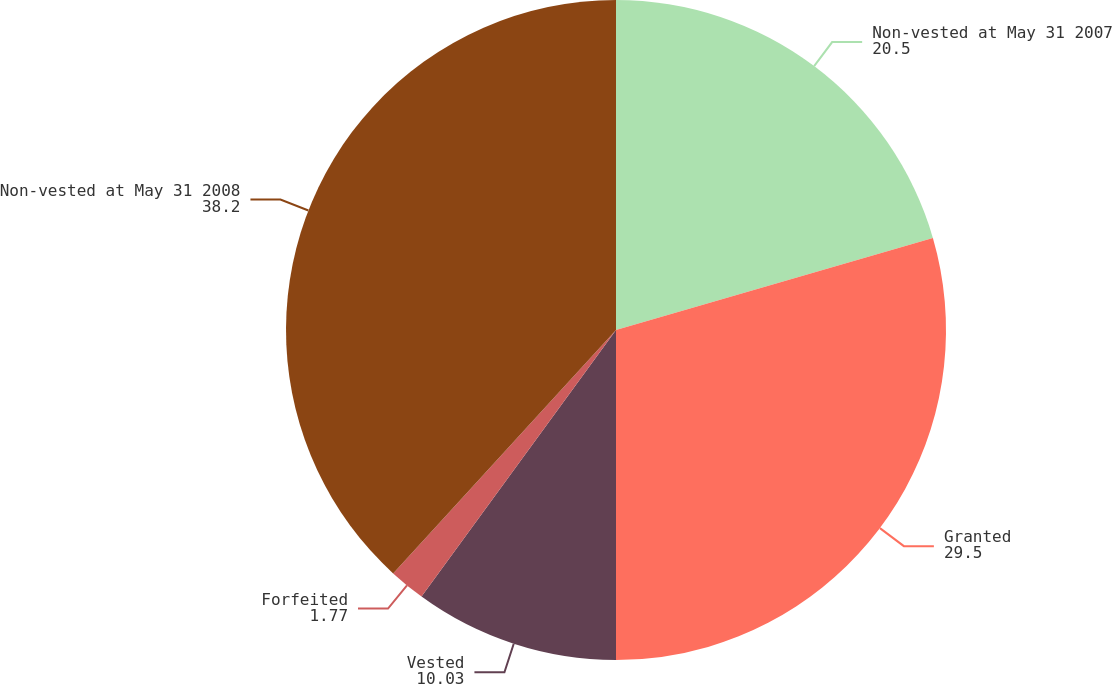Convert chart. <chart><loc_0><loc_0><loc_500><loc_500><pie_chart><fcel>Non-vested at May 31 2007<fcel>Granted<fcel>Vested<fcel>Forfeited<fcel>Non-vested at May 31 2008<nl><fcel>20.5%<fcel>29.5%<fcel>10.03%<fcel>1.77%<fcel>38.2%<nl></chart> 